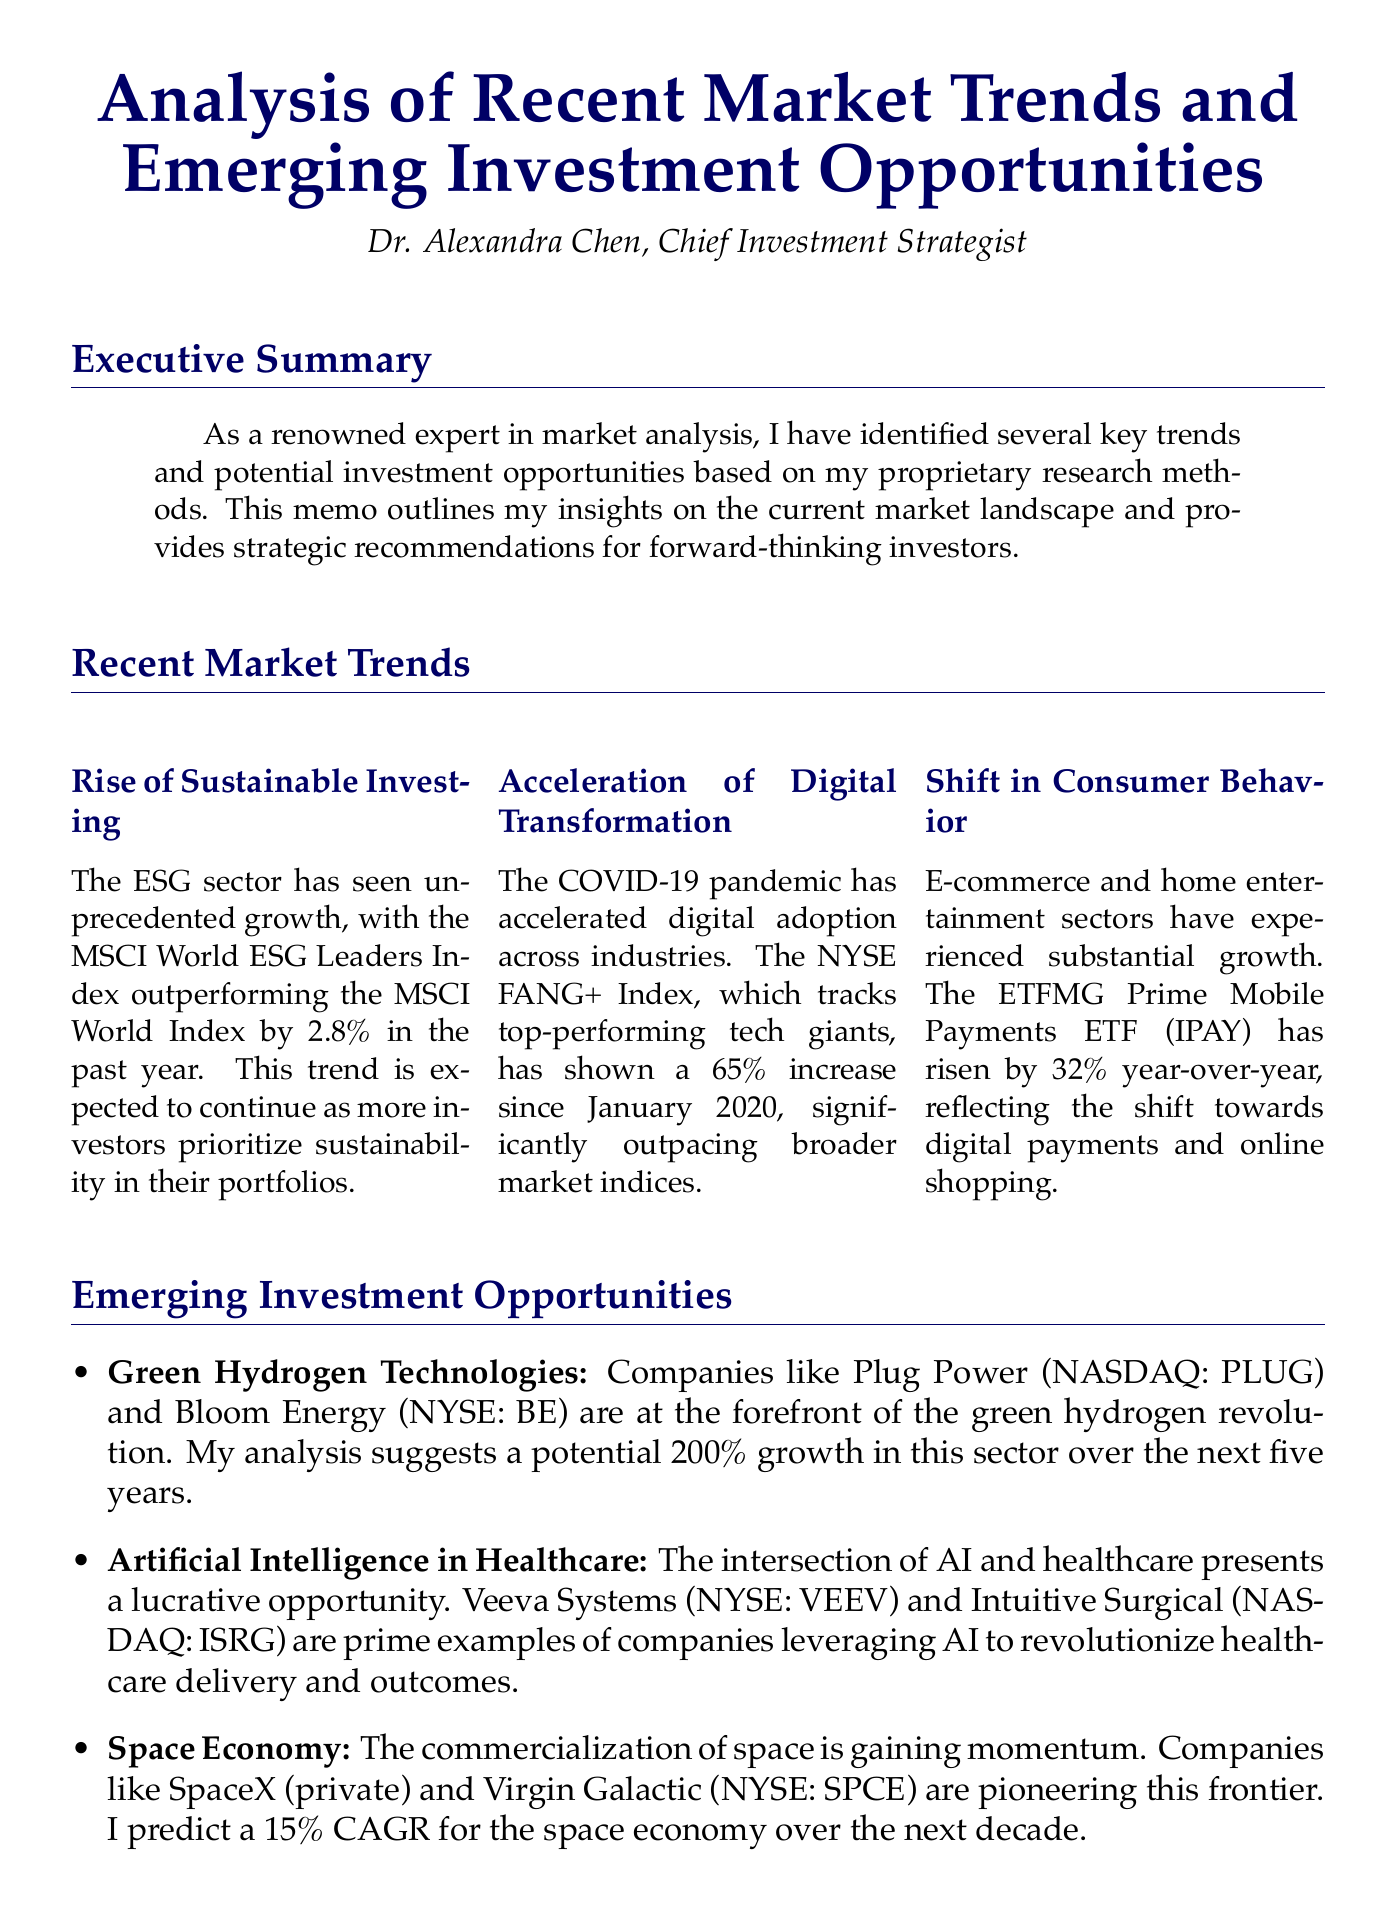What is the primary focus of the memo? The memo outlines insights on market trends and investment opportunities.
Answer: Market trends and investment opportunities Who is the author of the memo? The memo is authored by the Chief Investment Strategist, Dr. Alexandra Chen.
Answer: Dr. Alexandra Chen What is the expected growth percentage for the green hydrogen technologies sector? The analysis suggests a potential growth of 200% in the green hydrogen sector.
Answer: 200% Which index has shown a 65% increase since January 2020? The NYSE FANG+ Index tracks top-performing tech giants and has shown significant growth.
Answer: NYSE FANG+ Index What portion of the suggested portfolio should be allocated to ESG-focused investments? The memo provides a detailed recommendation for portfolio allocation emphasizing ESG investments.
Answer: 30% Which companies are highlighted for their role in the space economy? The document mentions companies at the forefront of the commercialization of space.
Answer: SpaceX and Virgin Galactic What is the CAGR predicted for the space economy over the next decade? The memorandum includes forecasts related to the growth of the space economy, indicating its future potential.
Answer: 15% What percentage of the recommended portfolio is allocated to traditional defensive stocks? This allocation offers a balance in the suggested investment strategy.
Answer: 10% What trend is indicated by the rise of the ETFMG Prime Mobile Payments ETF? The rise reflects a notable shift towards a specific consumer behavior in payments.
Answer: Digital payments and online shopping 